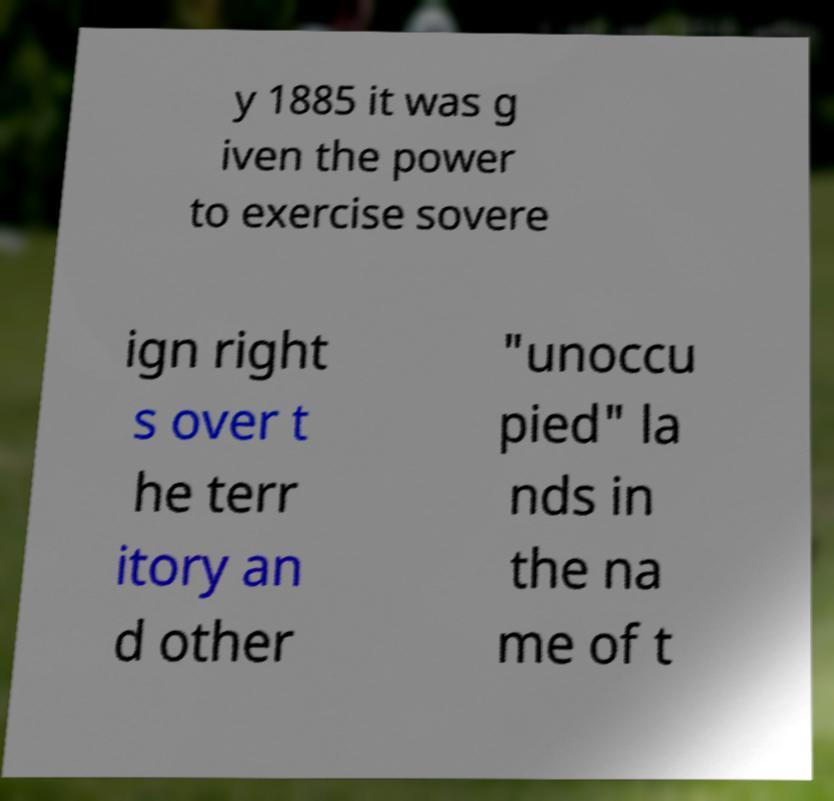Can you accurately transcribe the text from the provided image for me? y 1885 it was g iven the power to exercise sovere ign right s over t he terr itory an d other "unoccu pied" la nds in the na me of t 